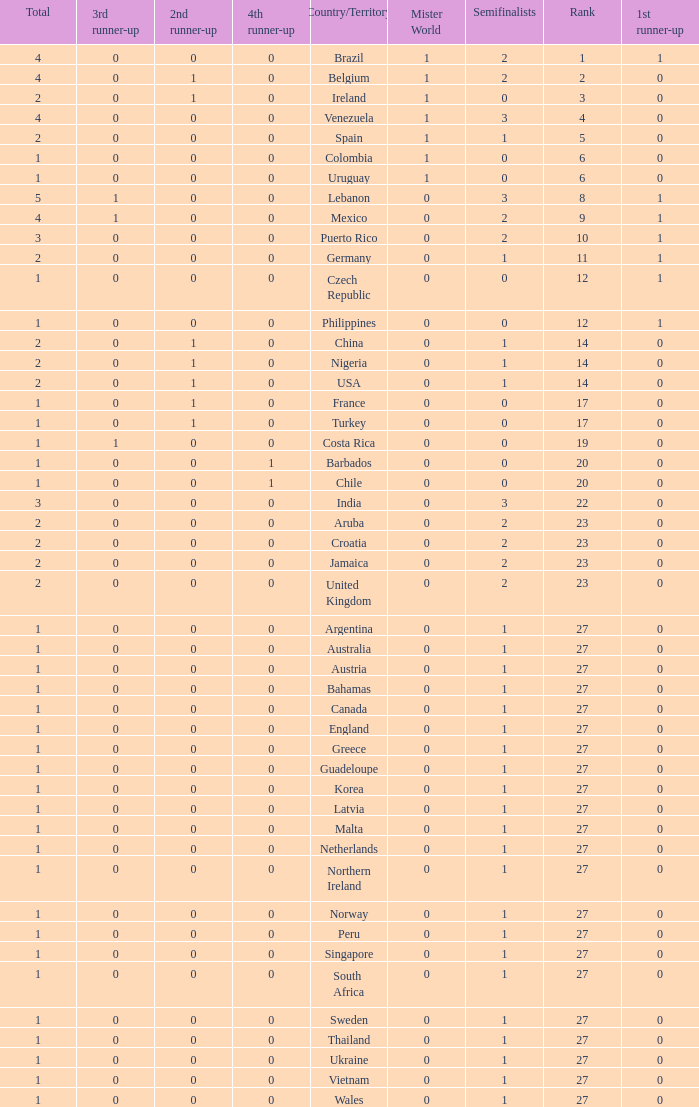What is the smallest 1st runner up value? 0.0. 